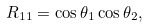Convert formula to latex. <formula><loc_0><loc_0><loc_500><loc_500>R _ { 1 1 } = \cos \theta _ { 1 } \cos \theta _ { 2 } ,</formula> 